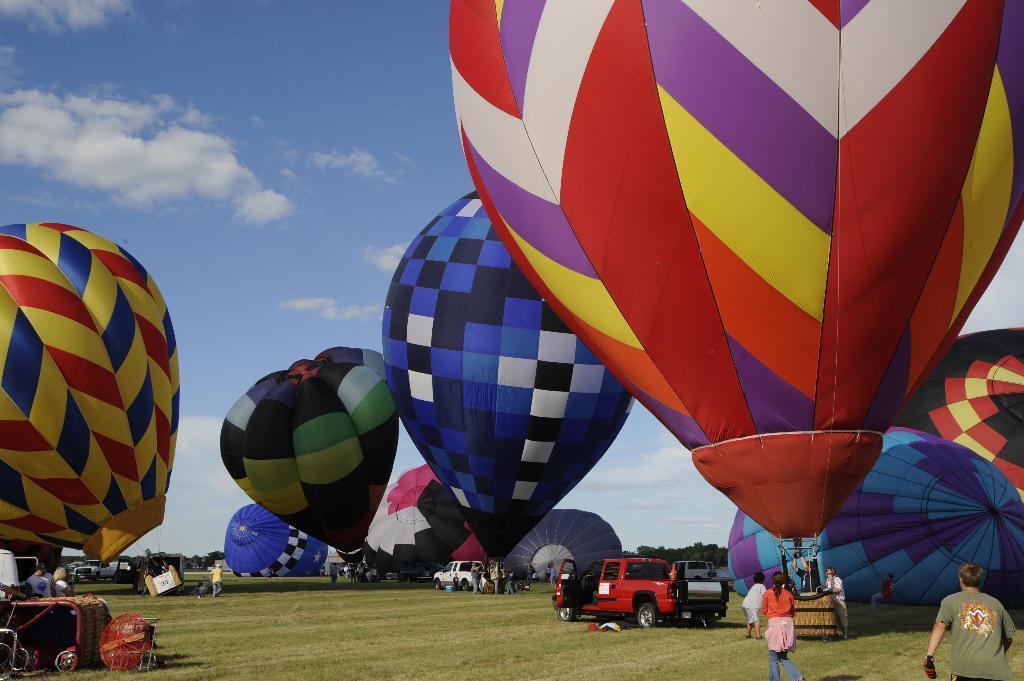Could you give a brief overview of what you see in this image? In this picture I can see there is a parachute and they are in different colors like red color, blue and yellow. The sky is clear. 